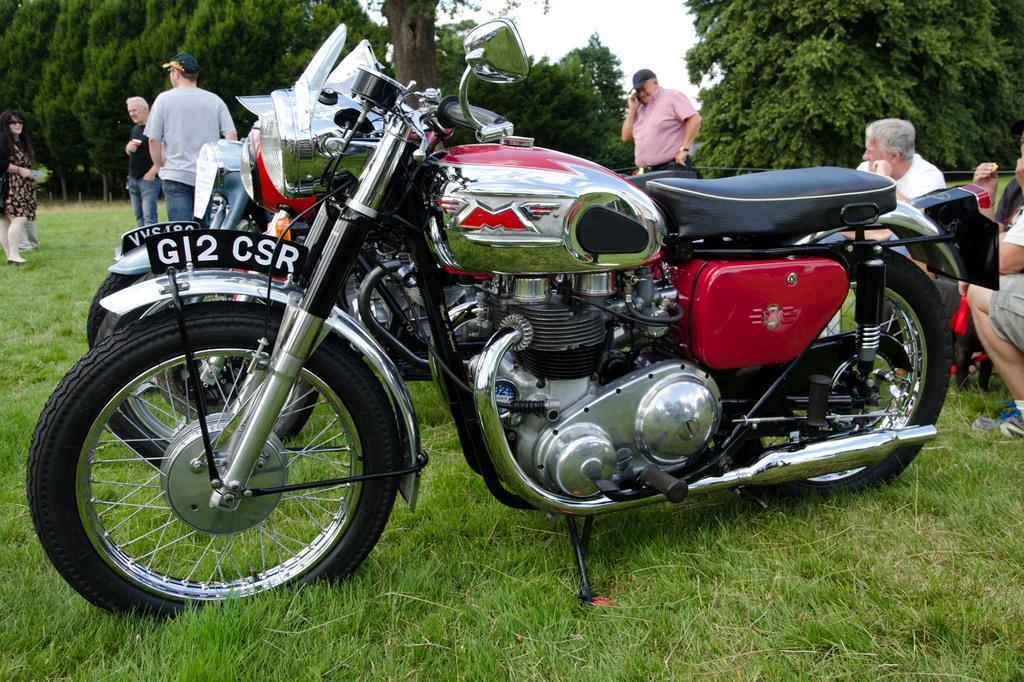Could you give a brief overview of what you see in this image? In this picture we can see few motorcycles on the grass, beside to the motorcycles we can find group of people, in the background we can find few trees. 